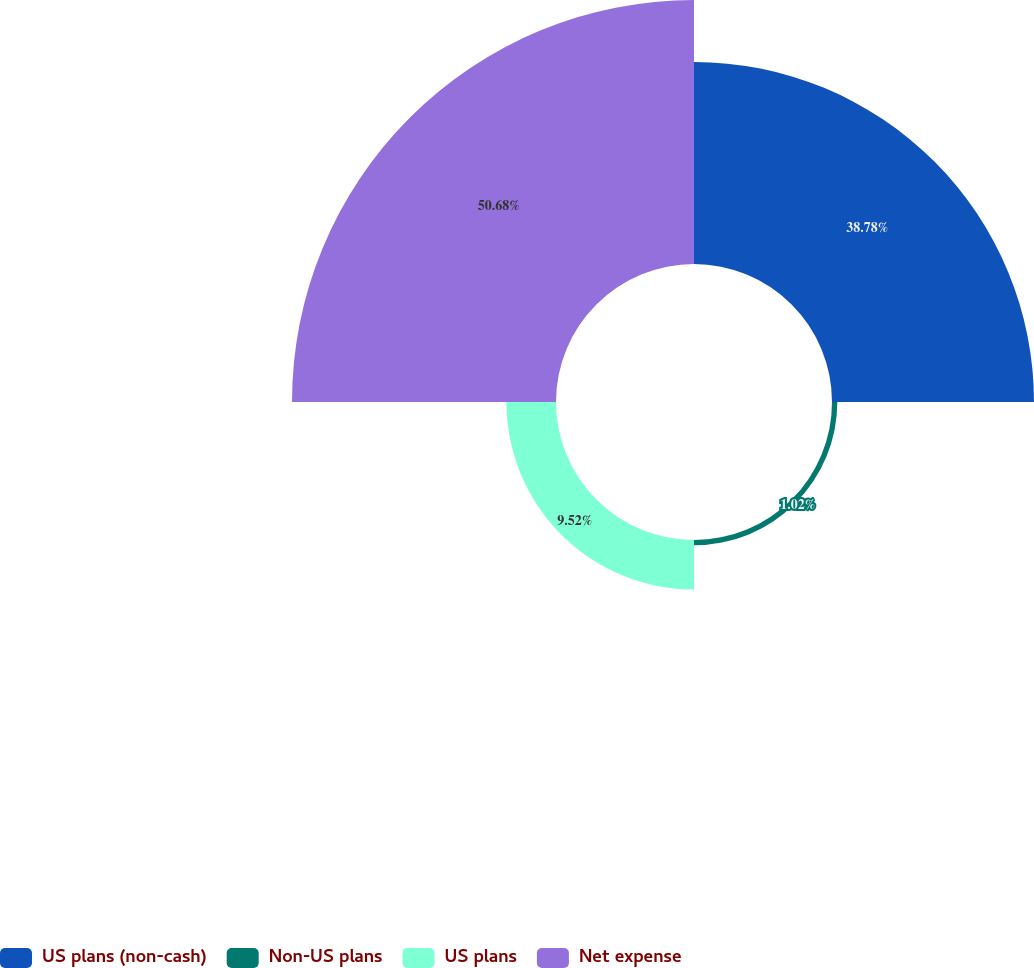<chart> <loc_0><loc_0><loc_500><loc_500><pie_chart><fcel>US plans (non-cash)<fcel>Non-US plans<fcel>US plans<fcel>Net expense<nl><fcel>38.78%<fcel>1.02%<fcel>9.52%<fcel>50.68%<nl></chart> 